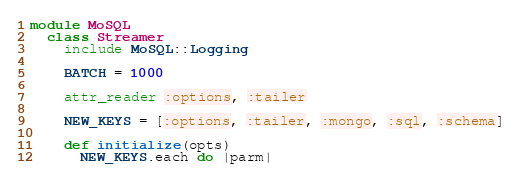Convert code to text. <code><loc_0><loc_0><loc_500><loc_500><_Ruby_>module MoSQL
  class Streamer
    include MoSQL::Logging

    BATCH = 1000

    attr_reader :options, :tailer

    NEW_KEYS = [:options, :tailer, :mongo, :sql, :schema]

    def initialize(opts)
      NEW_KEYS.each do |parm|</code> 